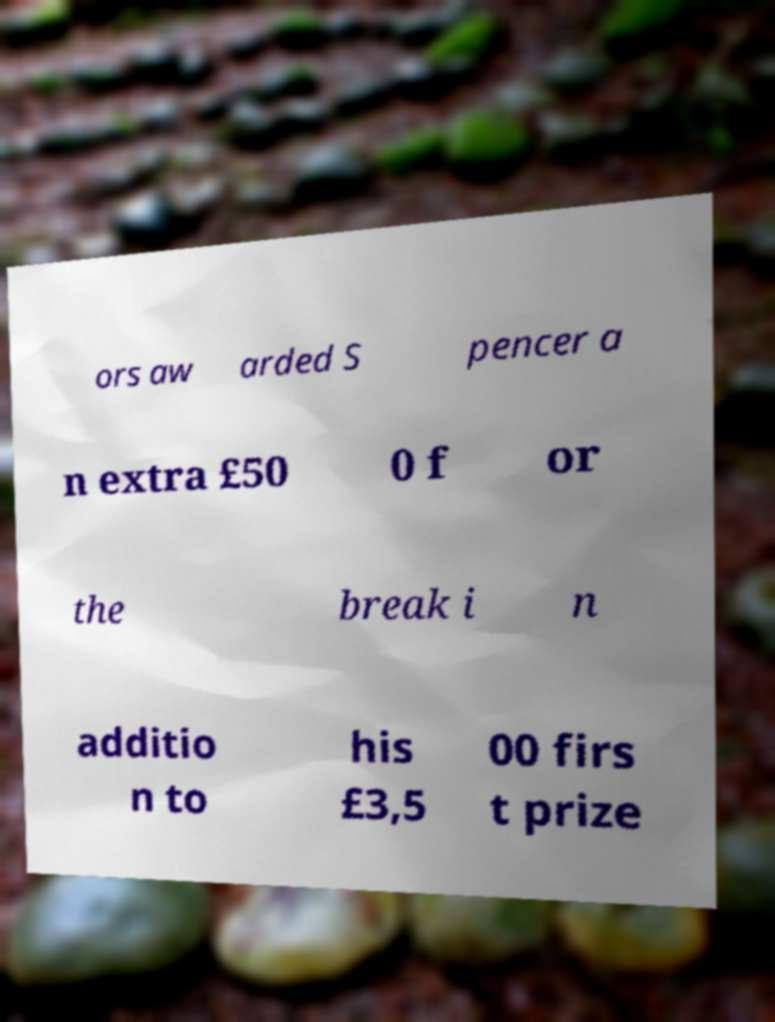What messages or text are displayed in this image? I need them in a readable, typed format. ors aw arded S pencer a n extra £50 0 f or the break i n additio n to his £3,5 00 firs t prize 